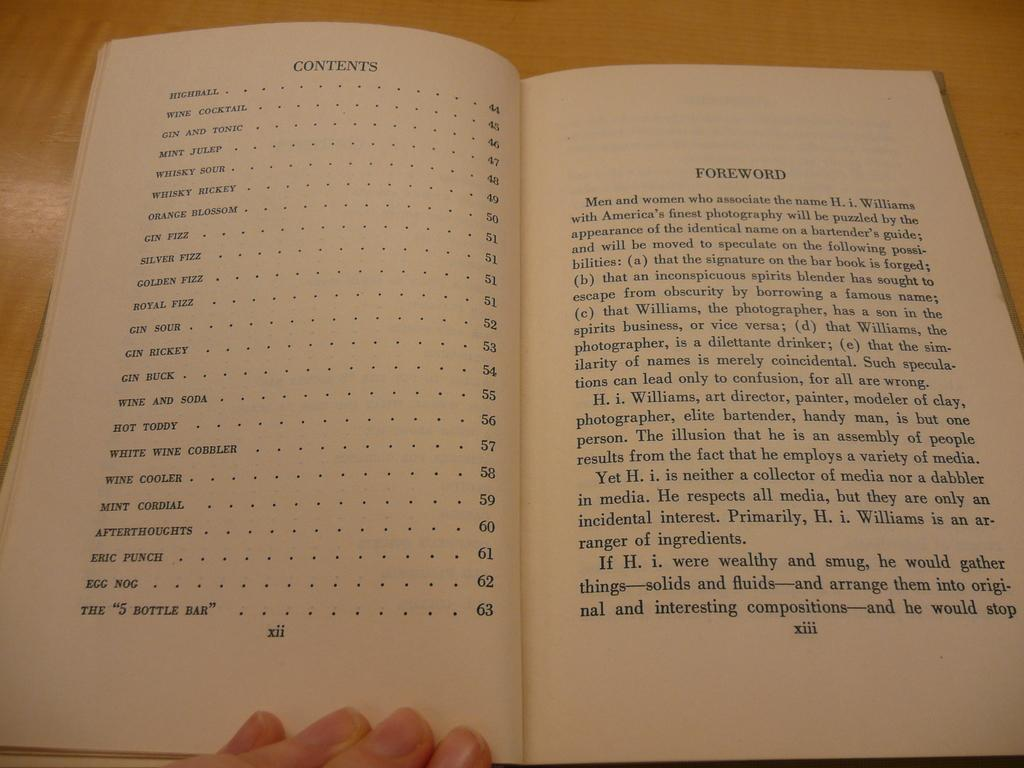<image>
Describe the image concisely. A book is open to the contents page and lists highball as the first chapter. 